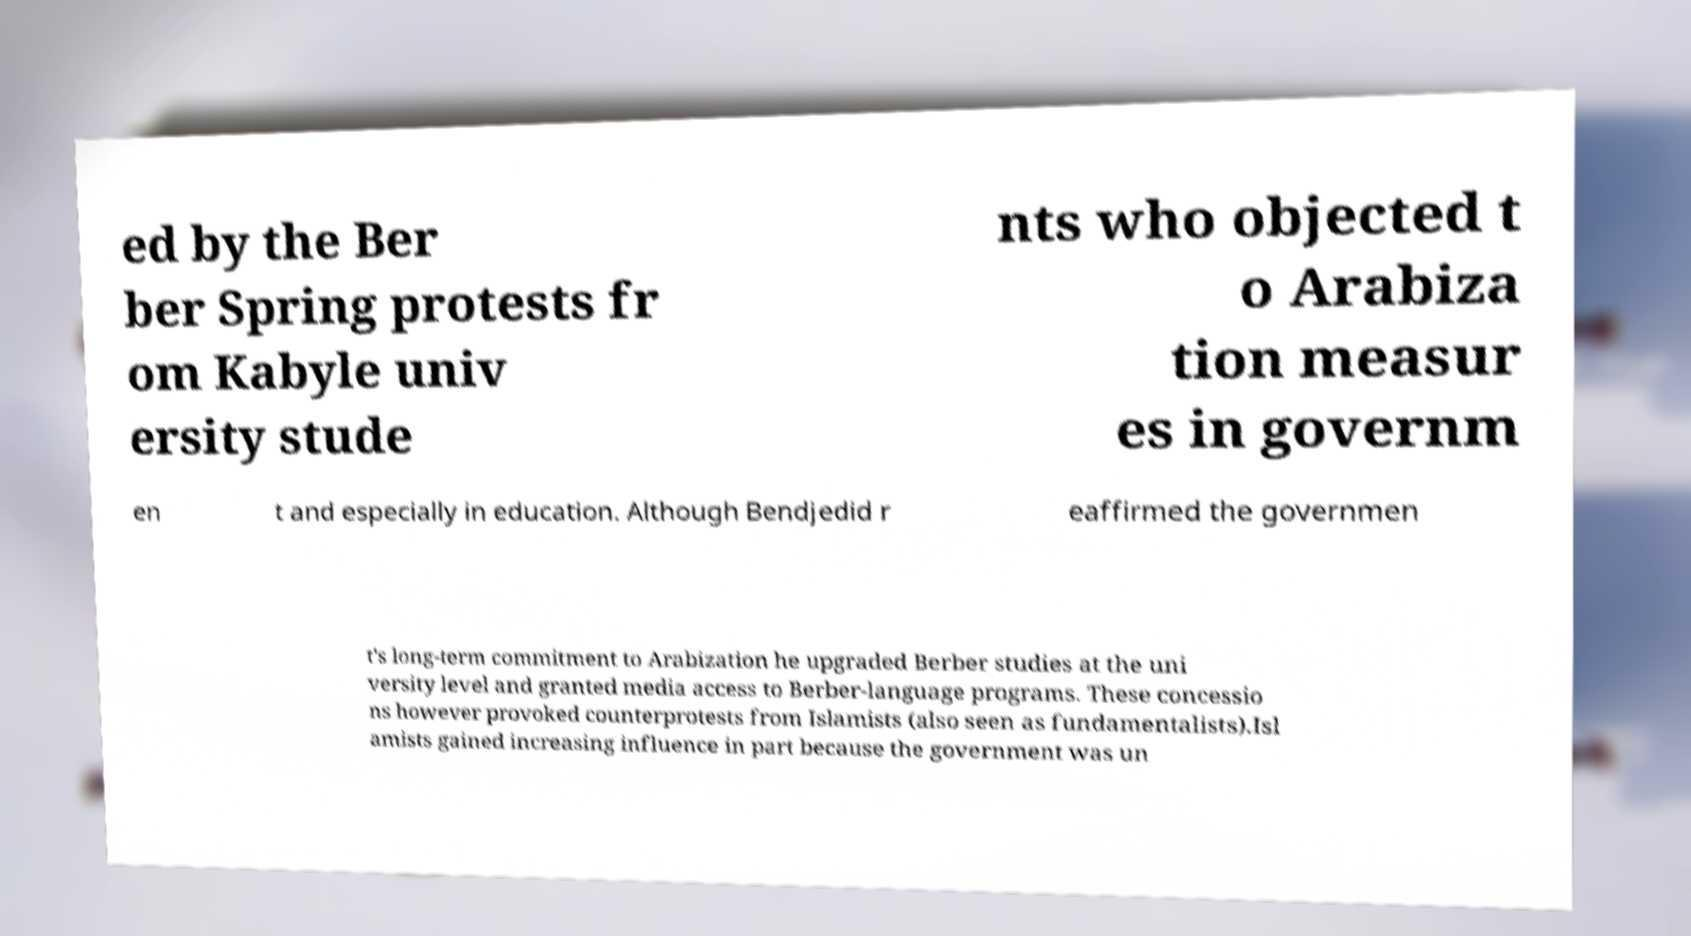I need the written content from this picture converted into text. Can you do that? ed by the Ber ber Spring protests fr om Kabyle univ ersity stude nts who objected t o Arabiza tion measur es in governm en t and especially in education. Although Bendjedid r eaffirmed the governmen t's long-term commitment to Arabization he upgraded Berber studies at the uni versity level and granted media access to Berber-language programs. These concessio ns however provoked counterprotests from Islamists (also seen as fundamentalists).Isl amists gained increasing influence in part because the government was un 